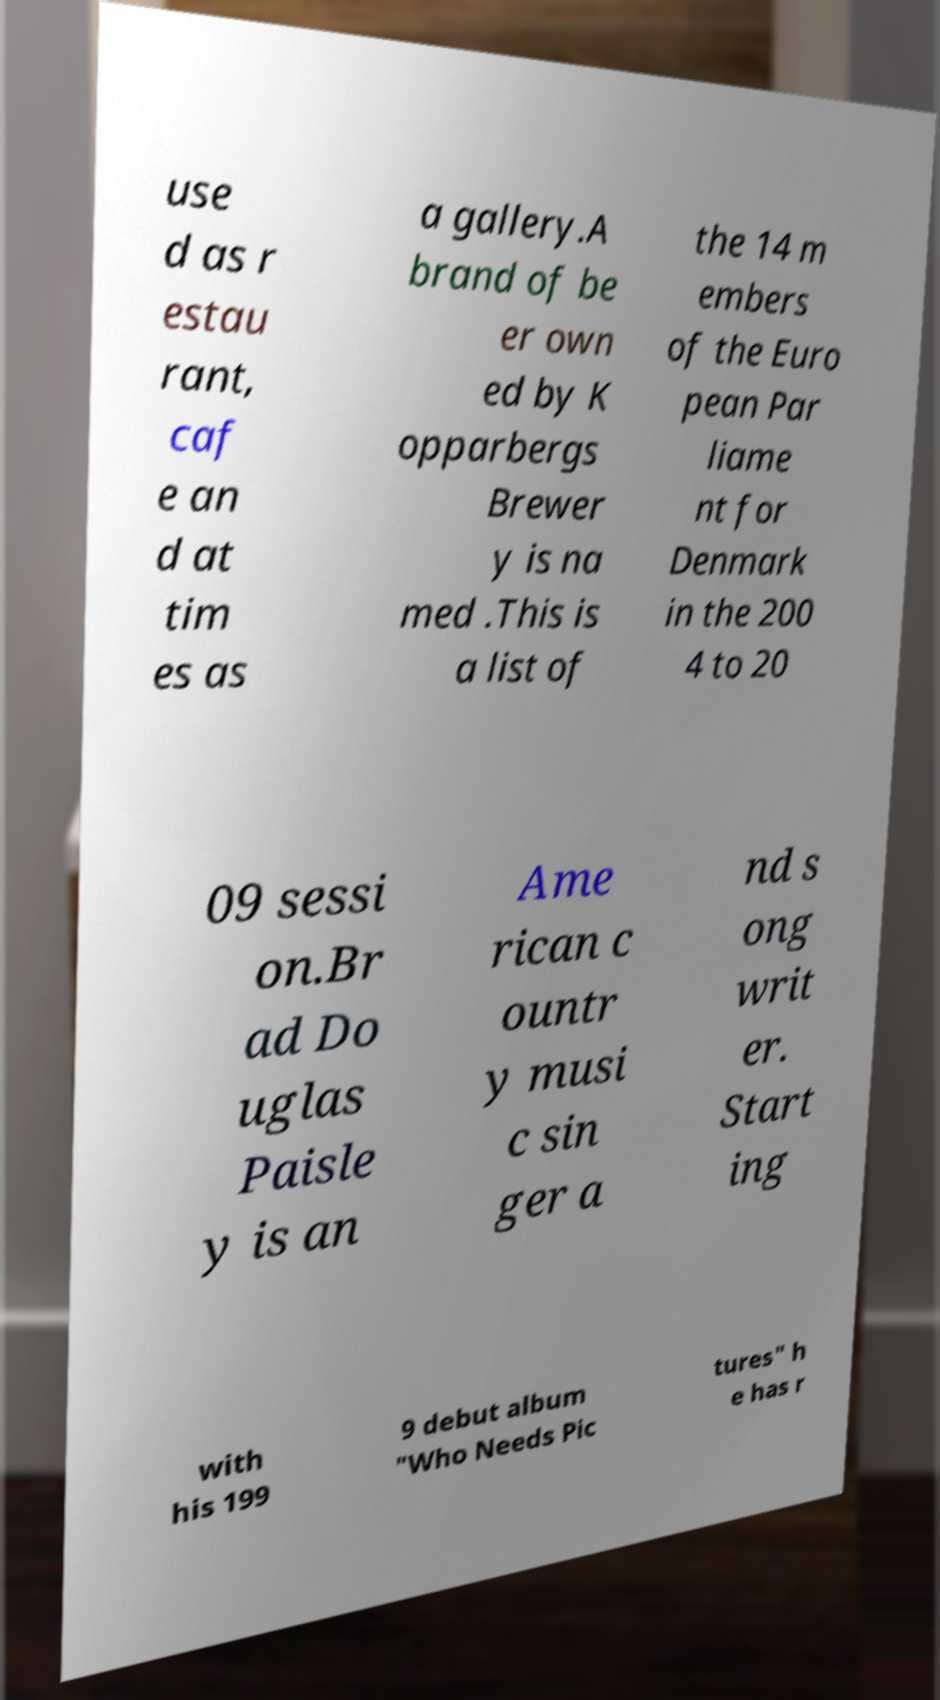Can you read and provide the text displayed in the image?This photo seems to have some interesting text. Can you extract and type it out for me? use d as r estau rant, caf e an d at tim es as a gallery.A brand of be er own ed by K opparbergs Brewer y is na med .This is a list of the 14 m embers of the Euro pean Par liame nt for Denmark in the 200 4 to 20 09 sessi on.Br ad Do uglas Paisle y is an Ame rican c ountr y musi c sin ger a nd s ong writ er. Start ing with his 199 9 debut album "Who Needs Pic tures" h e has r 